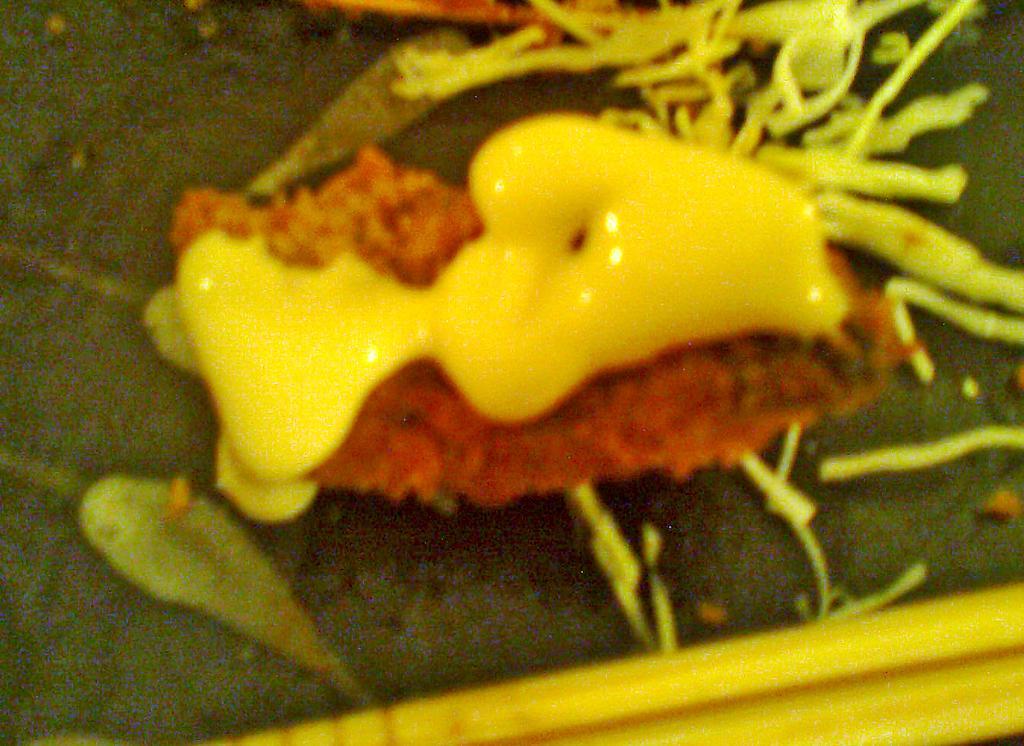How would you summarize this image in a sentence or two? In this picture they are looking like some food items on an object. 